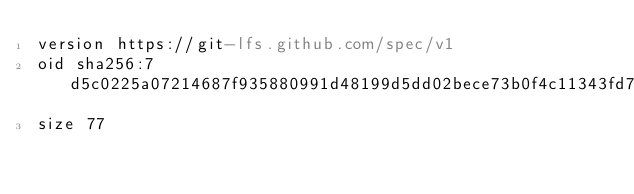Convert code to text. <code><loc_0><loc_0><loc_500><loc_500><_YAML_>version https://git-lfs.github.com/spec/v1
oid sha256:7d5c0225a07214687f935880991d48199d5dd02bece73b0f4c11343fd70ba060
size 77
</code> 